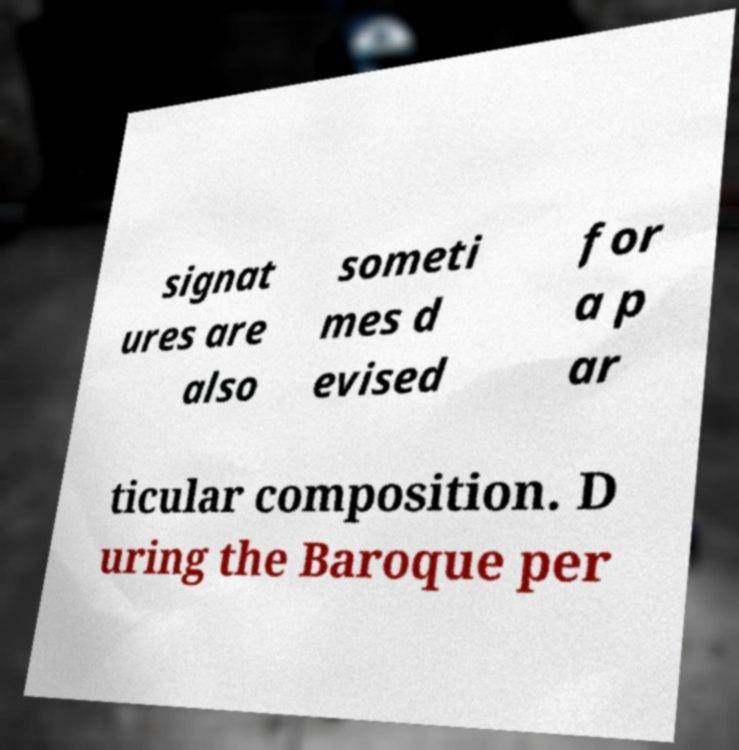For documentation purposes, I need the text within this image transcribed. Could you provide that? signat ures are also someti mes d evised for a p ar ticular composition. D uring the Baroque per 